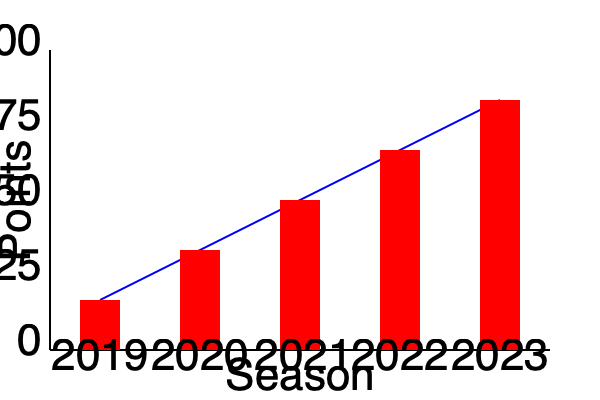Analyze the graph showing Royston FC's performance over the past five seasons. Calculate the average rate of increase in points per season and determine in which season the team showed the greatest improvement compared to the previous year. To solve this problem, we need to follow these steps:

1. Identify the points for each season:
   2019: 25 points
   2020: 50 points
   2021: 75 points
   2022: 100 points
   2023: 125 points

2. Calculate the average rate of increase in points per season:
   Total increase = 125 - 25 = 100 points
   Number of intervals = 4 (from 2019 to 2023)
   Average rate of increase = 100 / 4 = 25 points per season

3. Calculate the improvement for each season compared to the previous year:
   2020: 50 - 25 = 25 points improvement
   2021: 75 - 50 = 25 points improvement
   2022: 100 - 75 = 25 points improvement
   2023: 125 - 100 = 25 points improvement

4. Determine the season with the greatest improvement:
   All seasons show an equal improvement of 25 points compared to the previous year.

Therefore, the average rate of increase is 25 points per season, and the team showed consistent improvement across all seasons, with no single season standing out as having the greatest improvement.
Answer: Average rate: 25 points/season. Greatest improvement: Consistent across all seasons. 